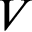Convert formula to latex. <formula><loc_0><loc_0><loc_500><loc_500>V</formula> 